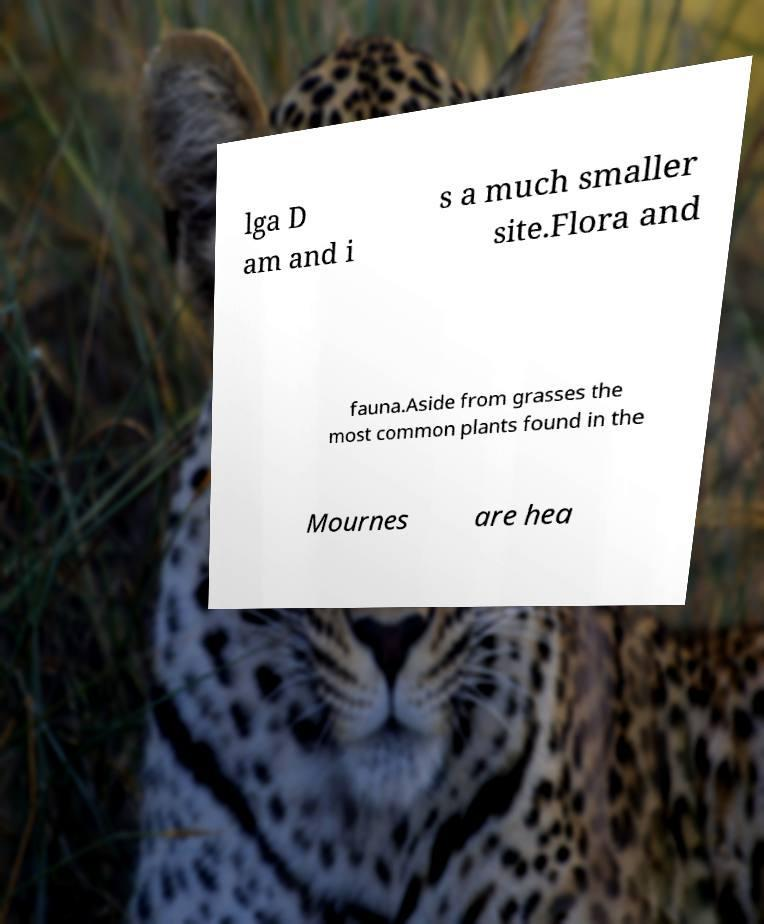There's text embedded in this image that I need extracted. Can you transcribe it verbatim? lga D am and i s a much smaller site.Flora and fauna.Aside from grasses the most common plants found in the Mournes are hea 